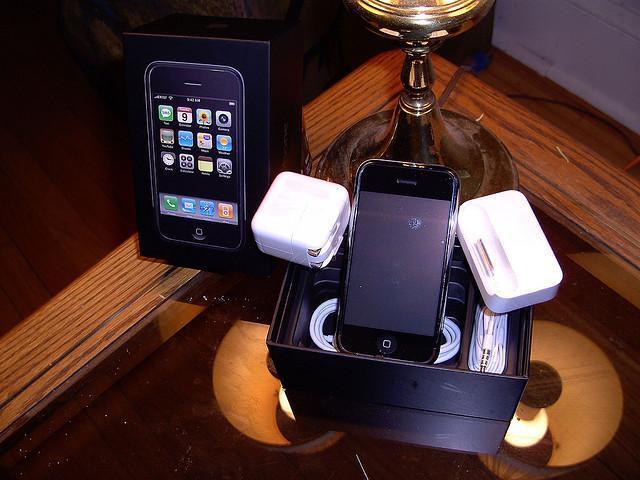How many cell phones are visible?
Give a very brief answer. 2. How many men are dressed in black?
Give a very brief answer. 0. 